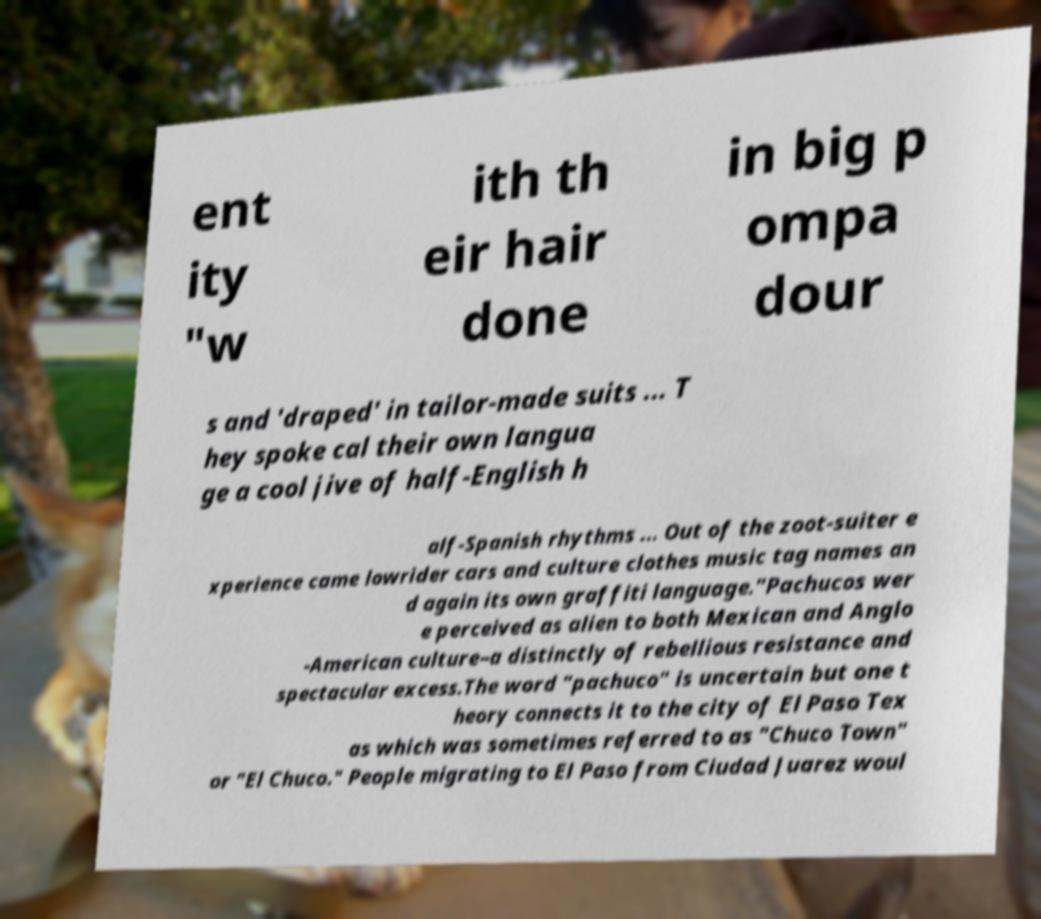I need the written content from this picture converted into text. Can you do that? ent ity "w ith th eir hair done in big p ompa dour s and 'draped' in tailor-made suits ... T hey spoke cal their own langua ge a cool jive of half-English h alf-Spanish rhythms ... Out of the zoot-suiter e xperience came lowrider cars and culture clothes music tag names an d again its own graffiti language."Pachucos wer e perceived as alien to both Mexican and Anglo -American culture–a distinctly of rebellious resistance and spectacular excess.The word "pachuco" is uncertain but one t heory connects it to the city of El Paso Tex as which was sometimes referred to as "Chuco Town" or "El Chuco." People migrating to El Paso from Ciudad Juarez woul 